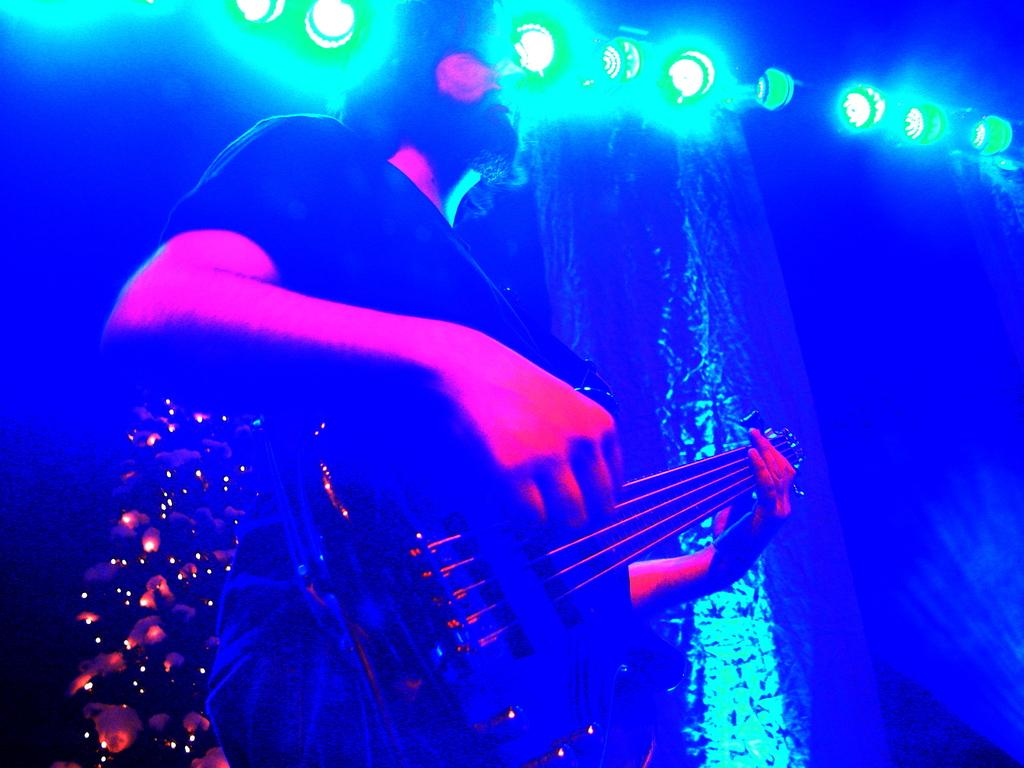What is the main subject of the image? There is a person in the image. What is the person doing in the image? The person is playing a guitar. Can you describe the person's attire in the image? The person is wearing clothes. What can be seen in the bottom left and top of the image? There are lights in the bottom left and top of the image. What type of structure does the expert use to perform the action in the image? There is no expert or specific structure mentioned in the image; it simply features a person playing a guitar. 